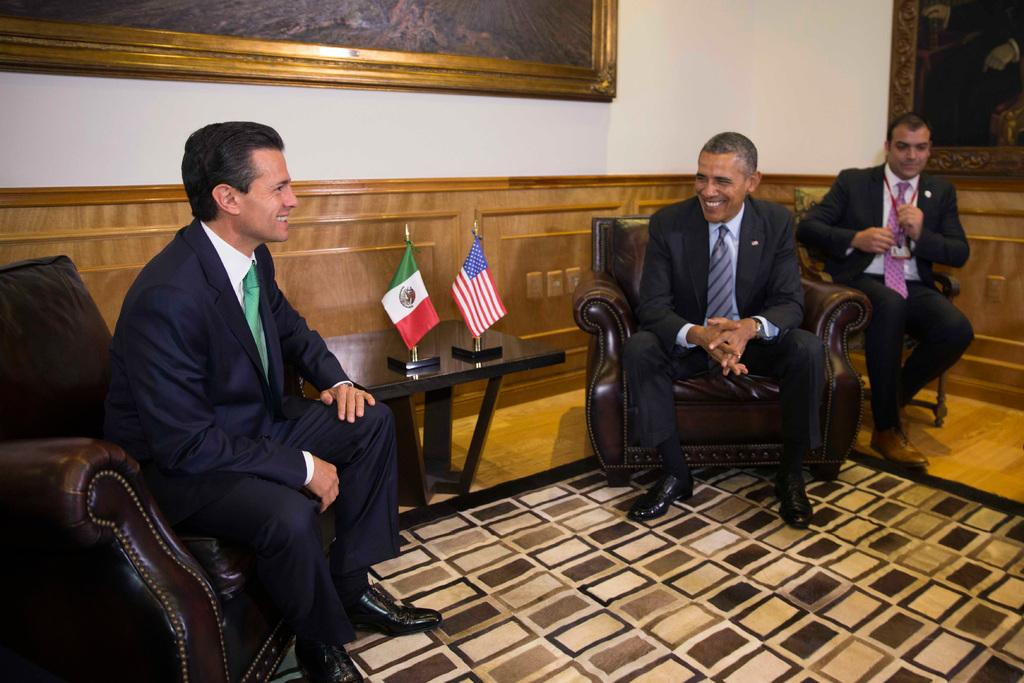How many people are in the image? There are three men in the image. What are the men doing in the image? The men are sitting on chairs. What can be seen on the table in the image? There are flags on a table in the image. What is on the wall in the image? There are frames on a wall in the image. What type of food is being served in the image? There is no food present in the image. Are the men in the image driving a vehicle? No, the men are sitting on chairs, not driving a vehicle. 